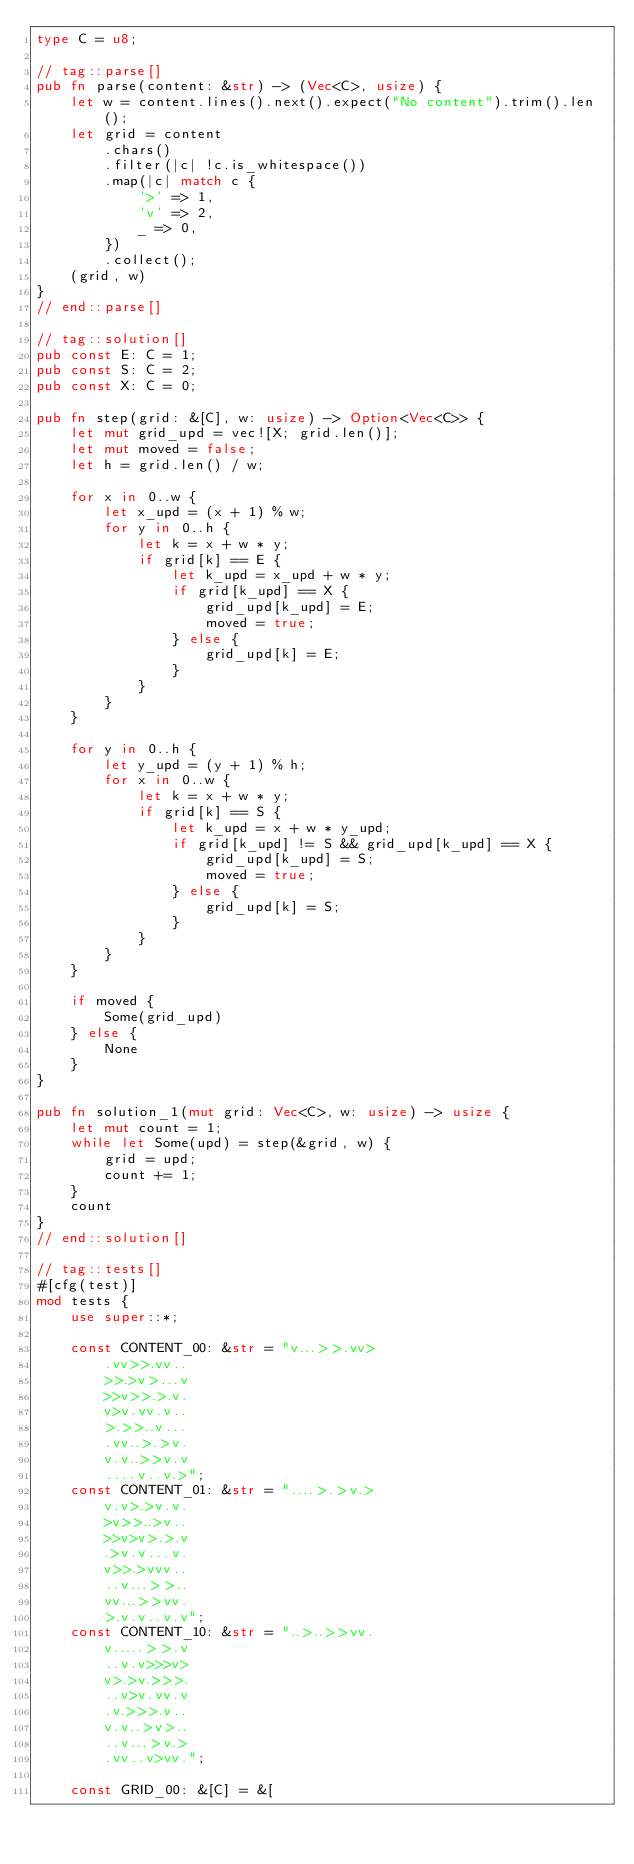<code> <loc_0><loc_0><loc_500><loc_500><_Rust_>type C = u8;

// tag::parse[]
pub fn parse(content: &str) -> (Vec<C>, usize) {
    let w = content.lines().next().expect("No content").trim().len();
    let grid = content
        .chars()
        .filter(|c| !c.is_whitespace())
        .map(|c| match c {
            '>' => 1,
            'v' => 2,
            _ => 0,
        })
        .collect();
    (grid, w)
}
// end::parse[]

// tag::solution[]
pub const E: C = 1;
pub const S: C = 2;
pub const X: C = 0;

pub fn step(grid: &[C], w: usize) -> Option<Vec<C>> {
    let mut grid_upd = vec![X; grid.len()];
    let mut moved = false;
    let h = grid.len() / w;

    for x in 0..w {
        let x_upd = (x + 1) % w;
        for y in 0..h {
            let k = x + w * y;
            if grid[k] == E {
                let k_upd = x_upd + w * y;
                if grid[k_upd] == X {
                    grid_upd[k_upd] = E;
                    moved = true;
                } else {
                    grid_upd[k] = E;
                }
            }
        }
    }

    for y in 0..h {
        let y_upd = (y + 1) % h;
        for x in 0..w {
            let k = x + w * y;
            if grid[k] == S {
                let k_upd = x + w * y_upd;
                if grid[k_upd] != S && grid_upd[k_upd] == X {
                    grid_upd[k_upd] = S;
                    moved = true;
                } else {
                    grid_upd[k] = S;
                }
            }
        }
    }

    if moved {
        Some(grid_upd)
    } else {
        None
    }
}

pub fn solution_1(mut grid: Vec<C>, w: usize) -> usize {
    let mut count = 1;
    while let Some(upd) = step(&grid, w) {
        grid = upd;
        count += 1;
    }
    count
}
// end::solution[]

// tag::tests[]
#[cfg(test)]
mod tests {
    use super::*;

    const CONTENT_00: &str = "v...>>.vv>
        .vv>>.vv..
        >>.>v>...v
        >>v>>.>.v.
        v>v.vv.v..
        >.>>..v...
        .vv..>.>v.
        v.v..>>v.v
        ....v..v.>";
    const CONTENT_01: &str = "....>.>v.>
        v.v>.>v.v.
        >v>>..>v..
        >>v>v>.>.v
        .>v.v...v.
        v>>.>vvv..
        ..v...>>..
        vv...>>vv.
        >.v.v..v.v";
    const CONTENT_10: &str = "..>..>>vv.
        v.....>>.v
        ..v.v>>>v>
        v>.>v.>>>.
        ..v>v.vv.v
        .v.>>>.v..
        v.v..>v>..
        ..v...>v.>
        .vv..v>vv.";

    const GRID_00: &[C] = &[</code> 